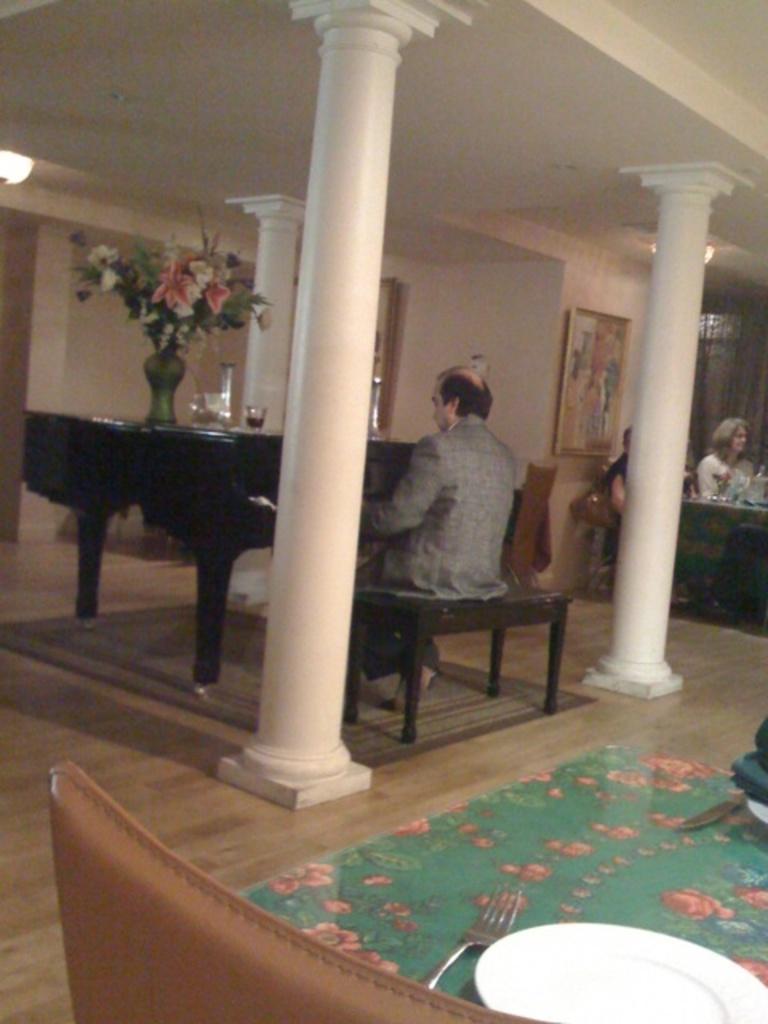How would you summarize this image in a sentence or two? There is a room. He is sitting in a chair. There is a table. There is a glass and flower vase on a table. On the right side we have women. She is sitting a chair. Behind him his plate on the sofa. We can in the background there is a pillar,wall and door. 